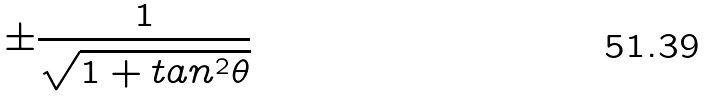<formula> <loc_0><loc_0><loc_500><loc_500>\pm \frac { 1 } { \sqrt { 1 + t a n ^ { 2 } \theta } }</formula> 